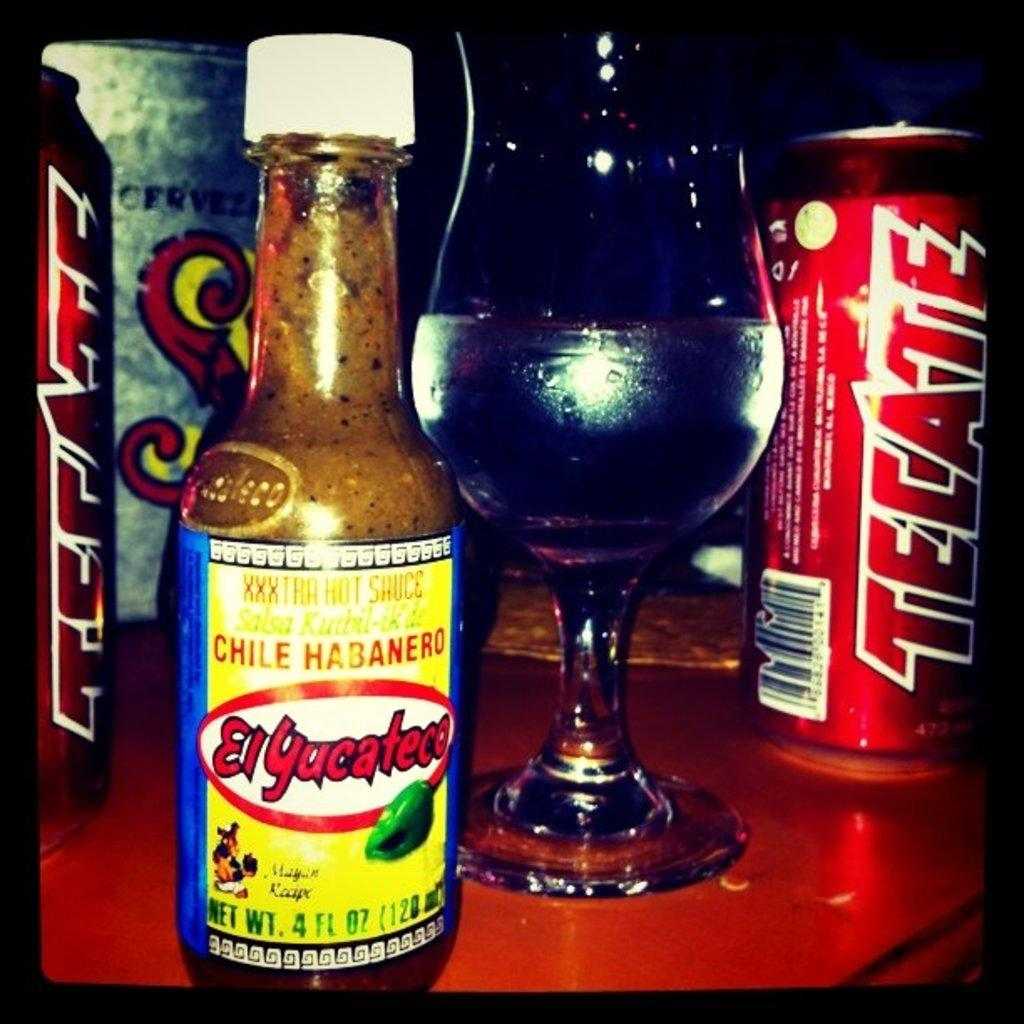What type of container is visible in the image? There is a bottle in the image. What other containers can be seen in the image? There is a glass and two cans in the image. Are there any labels or markings on the containers? Yes, there are words written on the bottle and the cans. What type of lock is used to secure the earth in the image? There is no lock or earth present in the image; it only features a bottle, glass, and cans with labels. 